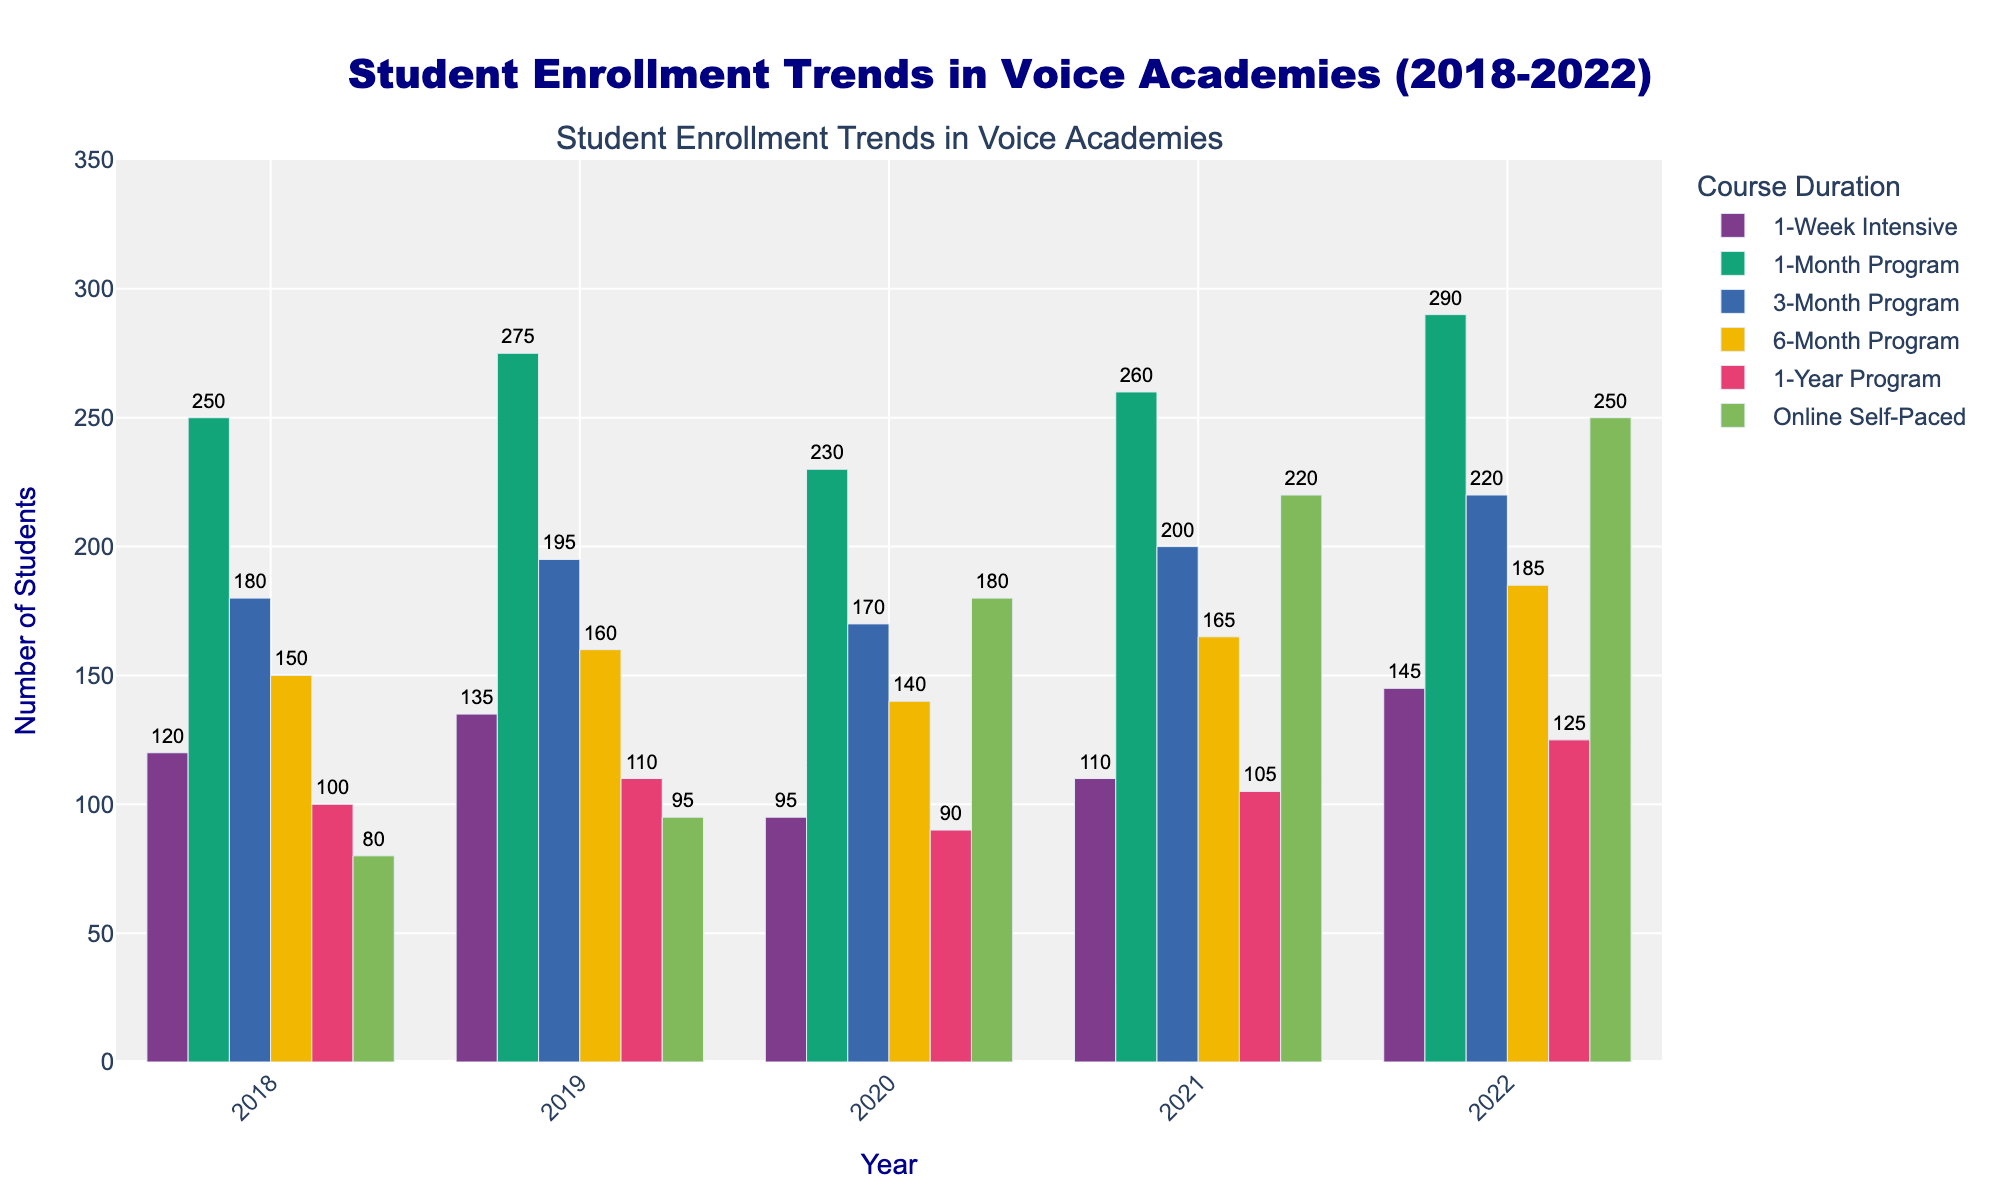What was the enrollment trend for the '1-Week Intensive' course from 2018 to 2022? Look at the bar heights for the '1-Week Intensive' course across the years. It starts at 120 in 2018, increases to 135 in 2019, drops to 95 in 2020, rises again to 110 in 2021, and finally reaches 145 in 2022.
Answer: Increases with fluctuations Which year had the highest total enrollment across all courses? Calculate the sum for each year by adding the student numbers for all courses. The totals are 880 (2018), 970 (2019), 905 (2020), 1060 (2021), and 1215 (2022). 2022 has the highest total enrollment.
Answer: 2022 By how much did the enrollment in the 'Online Self-Paced' course increase from 2018 to 2022? Subtract the number of students enrolled in 'Online Self-Paced' in 2018 from the number in 2022. 250 (2022) - 80 (2018) gives the increase.
Answer: 170 Which course had the most significant increase in enrollment between 2020 and 2022? Compare the difference between 2022 and 2020 enrollments for each course. 'Online Self-Paced' increased from 180 to 250, which is the most significant increase of 70.
Answer: Online Self-Paced How did the enrollment trend for the '1-Year Program' change from 2021 to 2022? Compare the bar heights for the '1-Year Program' in 2021 and 2022. Enrollment increased from 105 to 125.
Answer: Increased Compare the enrollment in the '3-Month Program' and '6-Month Program' in 2020. Which had more students? Look at the bar heights for both courses in 2020. '3-Month Program' has 170 students, while '6-Month Program' has 140 students.
Answer: 3-Month Program Which course had the smallest change in enrollment from 2018 to 2022? Calculate the absolute change (difference) for each course between 2018 and 2022. The '6-Month Program' changes from 150 to 185, giving a difference of 35, which is the smallest change.
Answer: 6-Month Program What was the average enrollment for the '1-Month Program' over the years 2018-2022? Add the enrollments for '1-Month Program': 250 (2018), 275 (2019), 230 (2020), 260 (2021), and 290 (2022). Total is 1305. Divide by 5 years to get the average: 1305 / 5.
Answer: 261 Which year had the lowest enrollment for the '1-Year Program'? Compare enrollments for '1-Year Program' across all years. It was 90 in 2020, the lowest.
Answer: 2020 Between which two consecutive years did the '1-Week Intensive' course see the largest increase? Calculate the increases between consecutive years. The largest increase is from 110 (2021) to 145 (2022), which is an increase of 35.
Answer: 2021 to 2022 